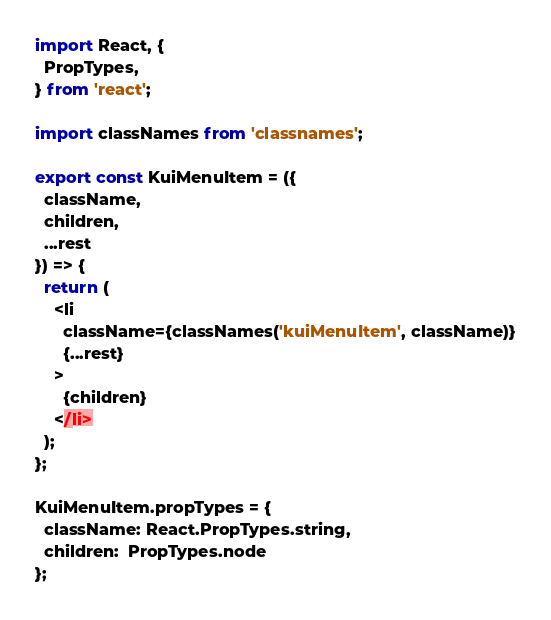<code> <loc_0><loc_0><loc_500><loc_500><_JavaScript_>import React, {
  PropTypes,
} from 'react';

import classNames from 'classnames';

export const KuiMenuItem = ({
  className,
  children,
  ...rest
}) => {
  return (
    <li
      className={classNames('kuiMenuItem', className)}
      {...rest}
    >
      {children}
    </li>
  );
};

KuiMenuItem.propTypes = {
  className: React.PropTypes.string,
  children:  PropTypes.node
};
</code> 